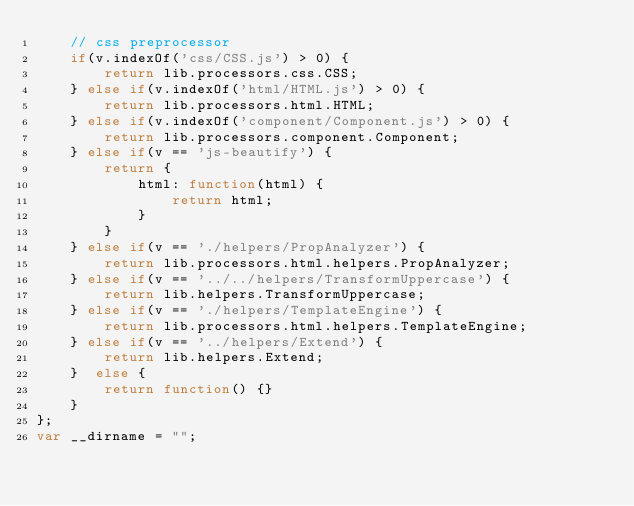Convert code to text. <code><loc_0><loc_0><loc_500><loc_500><_JavaScript_>	// css preprocessor
	if(v.indexOf('css/CSS.js') > 0) {
		return lib.processors.css.CSS;
	} else if(v.indexOf('html/HTML.js') > 0) {
		return lib.processors.html.HTML;
	} else if(v.indexOf('component/Component.js') > 0) {
		return lib.processors.component.Component;
	} else if(v == 'js-beautify') {
		return { 
			html: function(html) {
				return html;
			}
		}
	} else if(v == './helpers/PropAnalyzer') {
		return lib.processors.html.helpers.PropAnalyzer;
	} else if(v == '../../helpers/TransformUppercase') {
		return lib.helpers.TransformUppercase;
	} else if(v == './helpers/TemplateEngine') {
		return lib.processors.html.helpers.TemplateEngine;
	} else if(v == '../helpers/Extend') {
		return lib.helpers.Extend;
	}  else {
		return function() {}
	}
};
var __dirname = "";</code> 